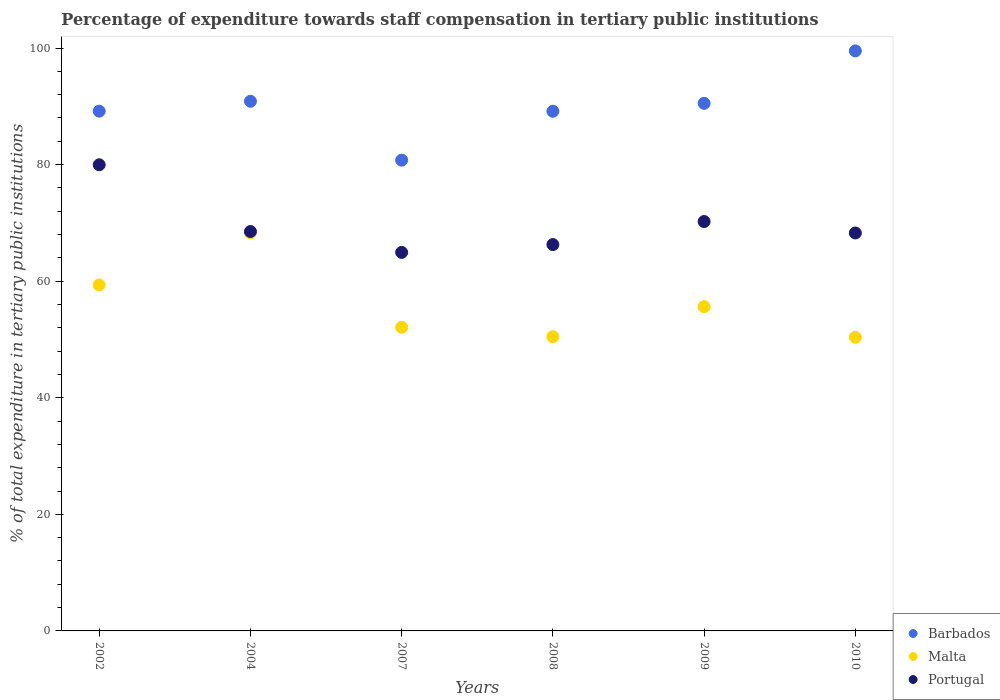How many different coloured dotlines are there?
Offer a terse response. 3. Is the number of dotlines equal to the number of legend labels?
Provide a succinct answer. Yes. What is the percentage of expenditure towards staff compensation in Malta in 2004?
Your response must be concise. 68.29. Across all years, what is the maximum percentage of expenditure towards staff compensation in Barbados?
Give a very brief answer. 99.51. Across all years, what is the minimum percentage of expenditure towards staff compensation in Barbados?
Provide a short and direct response. 80.77. In which year was the percentage of expenditure towards staff compensation in Barbados maximum?
Your response must be concise. 2010. In which year was the percentage of expenditure towards staff compensation in Barbados minimum?
Offer a terse response. 2007. What is the total percentage of expenditure towards staff compensation in Portugal in the graph?
Offer a very short reply. 418.22. What is the difference between the percentage of expenditure towards staff compensation in Portugal in 2004 and that in 2007?
Your answer should be compact. 3.59. What is the difference between the percentage of expenditure towards staff compensation in Portugal in 2002 and the percentage of expenditure towards staff compensation in Malta in 2010?
Provide a succinct answer. 29.59. What is the average percentage of expenditure towards staff compensation in Barbados per year?
Ensure brevity in your answer.  90. In the year 2004, what is the difference between the percentage of expenditure towards staff compensation in Barbados and percentage of expenditure towards staff compensation in Portugal?
Make the answer very short. 22.34. In how many years, is the percentage of expenditure towards staff compensation in Barbados greater than 24 %?
Offer a very short reply. 6. What is the ratio of the percentage of expenditure towards staff compensation in Barbados in 2004 to that in 2008?
Your answer should be very brief. 1.02. Is the percentage of expenditure towards staff compensation in Barbados in 2007 less than that in 2008?
Ensure brevity in your answer.  Yes. Is the difference between the percentage of expenditure towards staff compensation in Barbados in 2007 and 2009 greater than the difference between the percentage of expenditure towards staff compensation in Portugal in 2007 and 2009?
Offer a terse response. No. What is the difference between the highest and the second highest percentage of expenditure towards staff compensation in Portugal?
Your answer should be compact. 9.74. What is the difference between the highest and the lowest percentage of expenditure towards staff compensation in Barbados?
Offer a terse response. 18.74. In how many years, is the percentage of expenditure towards staff compensation in Barbados greater than the average percentage of expenditure towards staff compensation in Barbados taken over all years?
Ensure brevity in your answer.  3. Is it the case that in every year, the sum of the percentage of expenditure towards staff compensation in Barbados and percentage of expenditure towards staff compensation in Portugal  is greater than the percentage of expenditure towards staff compensation in Malta?
Offer a very short reply. Yes. Does the percentage of expenditure towards staff compensation in Portugal monotonically increase over the years?
Give a very brief answer. No. Is the percentage of expenditure towards staff compensation in Portugal strictly greater than the percentage of expenditure towards staff compensation in Barbados over the years?
Provide a succinct answer. No. How many years are there in the graph?
Keep it short and to the point. 6. Are the values on the major ticks of Y-axis written in scientific E-notation?
Provide a succinct answer. No. Where does the legend appear in the graph?
Provide a succinct answer. Bottom right. What is the title of the graph?
Your response must be concise. Percentage of expenditure towards staff compensation in tertiary public institutions. Does "Sudan" appear as one of the legend labels in the graph?
Provide a short and direct response. No. What is the label or title of the X-axis?
Make the answer very short. Years. What is the label or title of the Y-axis?
Provide a short and direct response. % of total expenditure in tertiary public institutions. What is the % of total expenditure in tertiary public institutions in Barbados in 2002?
Make the answer very short. 89.17. What is the % of total expenditure in tertiary public institutions in Malta in 2002?
Give a very brief answer. 59.36. What is the % of total expenditure in tertiary public institutions of Portugal in 2002?
Offer a terse response. 79.97. What is the % of total expenditure in tertiary public institutions in Barbados in 2004?
Keep it short and to the point. 90.87. What is the % of total expenditure in tertiary public institutions of Malta in 2004?
Your response must be concise. 68.29. What is the % of total expenditure in tertiary public institutions in Portugal in 2004?
Keep it short and to the point. 68.52. What is the % of total expenditure in tertiary public institutions of Barbados in 2007?
Ensure brevity in your answer.  80.77. What is the % of total expenditure in tertiary public institutions of Malta in 2007?
Give a very brief answer. 52.09. What is the % of total expenditure in tertiary public institutions of Portugal in 2007?
Provide a succinct answer. 64.94. What is the % of total expenditure in tertiary public institutions of Barbados in 2008?
Ensure brevity in your answer.  89.15. What is the % of total expenditure in tertiary public institutions of Malta in 2008?
Provide a short and direct response. 50.48. What is the % of total expenditure in tertiary public institutions of Portugal in 2008?
Your response must be concise. 66.28. What is the % of total expenditure in tertiary public institutions in Barbados in 2009?
Keep it short and to the point. 90.51. What is the % of total expenditure in tertiary public institutions of Malta in 2009?
Your answer should be compact. 55.62. What is the % of total expenditure in tertiary public institutions of Portugal in 2009?
Make the answer very short. 70.24. What is the % of total expenditure in tertiary public institutions of Barbados in 2010?
Your answer should be very brief. 99.51. What is the % of total expenditure in tertiary public institutions of Malta in 2010?
Your response must be concise. 50.38. What is the % of total expenditure in tertiary public institutions in Portugal in 2010?
Provide a succinct answer. 68.27. Across all years, what is the maximum % of total expenditure in tertiary public institutions of Barbados?
Provide a short and direct response. 99.51. Across all years, what is the maximum % of total expenditure in tertiary public institutions of Malta?
Your answer should be very brief. 68.29. Across all years, what is the maximum % of total expenditure in tertiary public institutions in Portugal?
Provide a short and direct response. 79.97. Across all years, what is the minimum % of total expenditure in tertiary public institutions in Barbados?
Provide a succinct answer. 80.77. Across all years, what is the minimum % of total expenditure in tertiary public institutions of Malta?
Your answer should be compact. 50.38. Across all years, what is the minimum % of total expenditure in tertiary public institutions in Portugal?
Give a very brief answer. 64.94. What is the total % of total expenditure in tertiary public institutions of Barbados in the graph?
Keep it short and to the point. 539.98. What is the total % of total expenditure in tertiary public institutions of Malta in the graph?
Offer a terse response. 336.22. What is the total % of total expenditure in tertiary public institutions of Portugal in the graph?
Ensure brevity in your answer.  418.22. What is the difference between the % of total expenditure in tertiary public institutions of Barbados in 2002 and that in 2004?
Ensure brevity in your answer.  -1.7. What is the difference between the % of total expenditure in tertiary public institutions of Malta in 2002 and that in 2004?
Offer a terse response. -8.93. What is the difference between the % of total expenditure in tertiary public institutions of Portugal in 2002 and that in 2004?
Keep it short and to the point. 11.45. What is the difference between the % of total expenditure in tertiary public institutions in Barbados in 2002 and that in 2007?
Offer a very short reply. 8.4. What is the difference between the % of total expenditure in tertiary public institutions in Malta in 2002 and that in 2007?
Your answer should be compact. 7.26. What is the difference between the % of total expenditure in tertiary public institutions in Portugal in 2002 and that in 2007?
Provide a short and direct response. 15.04. What is the difference between the % of total expenditure in tertiary public institutions in Barbados in 2002 and that in 2008?
Provide a short and direct response. 0.02. What is the difference between the % of total expenditure in tertiary public institutions in Malta in 2002 and that in 2008?
Give a very brief answer. 8.87. What is the difference between the % of total expenditure in tertiary public institutions of Portugal in 2002 and that in 2008?
Ensure brevity in your answer.  13.69. What is the difference between the % of total expenditure in tertiary public institutions of Barbados in 2002 and that in 2009?
Make the answer very short. -1.34. What is the difference between the % of total expenditure in tertiary public institutions in Malta in 2002 and that in 2009?
Provide a succinct answer. 3.73. What is the difference between the % of total expenditure in tertiary public institutions of Portugal in 2002 and that in 2009?
Your answer should be compact. 9.74. What is the difference between the % of total expenditure in tertiary public institutions in Barbados in 2002 and that in 2010?
Your answer should be compact. -10.34. What is the difference between the % of total expenditure in tertiary public institutions in Malta in 2002 and that in 2010?
Provide a short and direct response. 8.98. What is the difference between the % of total expenditure in tertiary public institutions of Portugal in 2002 and that in 2010?
Your answer should be compact. 11.7. What is the difference between the % of total expenditure in tertiary public institutions in Barbados in 2004 and that in 2007?
Provide a short and direct response. 10.1. What is the difference between the % of total expenditure in tertiary public institutions of Malta in 2004 and that in 2007?
Your answer should be compact. 16.2. What is the difference between the % of total expenditure in tertiary public institutions of Portugal in 2004 and that in 2007?
Keep it short and to the point. 3.59. What is the difference between the % of total expenditure in tertiary public institutions in Barbados in 2004 and that in 2008?
Make the answer very short. 1.72. What is the difference between the % of total expenditure in tertiary public institutions of Malta in 2004 and that in 2008?
Provide a short and direct response. 17.81. What is the difference between the % of total expenditure in tertiary public institutions of Portugal in 2004 and that in 2008?
Give a very brief answer. 2.24. What is the difference between the % of total expenditure in tertiary public institutions in Barbados in 2004 and that in 2009?
Provide a succinct answer. 0.36. What is the difference between the % of total expenditure in tertiary public institutions in Malta in 2004 and that in 2009?
Your response must be concise. 12.66. What is the difference between the % of total expenditure in tertiary public institutions of Portugal in 2004 and that in 2009?
Your answer should be very brief. -1.71. What is the difference between the % of total expenditure in tertiary public institutions in Barbados in 2004 and that in 2010?
Offer a terse response. -8.64. What is the difference between the % of total expenditure in tertiary public institutions in Malta in 2004 and that in 2010?
Ensure brevity in your answer.  17.91. What is the difference between the % of total expenditure in tertiary public institutions of Portugal in 2004 and that in 2010?
Keep it short and to the point. 0.25. What is the difference between the % of total expenditure in tertiary public institutions in Barbados in 2007 and that in 2008?
Offer a terse response. -8.38. What is the difference between the % of total expenditure in tertiary public institutions of Malta in 2007 and that in 2008?
Ensure brevity in your answer.  1.61. What is the difference between the % of total expenditure in tertiary public institutions in Portugal in 2007 and that in 2008?
Offer a very short reply. -1.35. What is the difference between the % of total expenditure in tertiary public institutions of Barbados in 2007 and that in 2009?
Provide a succinct answer. -9.74. What is the difference between the % of total expenditure in tertiary public institutions of Malta in 2007 and that in 2009?
Ensure brevity in your answer.  -3.53. What is the difference between the % of total expenditure in tertiary public institutions of Portugal in 2007 and that in 2009?
Your answer should be compact. -5.3. What is the difference between the % of total expenditure in tertiary public institutions of Barbados in 2007 and that in 2010?
Make the answer very short. -18.74. What is the difference between the % of total expenditure in tertiary public institutions in Malta in 2007 and that in 2010?
Provide a short and direct response. 1.72. What is the difference between the % of total expenditure in tertiary public institutions of Portugal in 2007 and that in 2010?
Your answer should be very brief. -3.33. What is the difference between the % of total expenditure in tertiary public institutions in Barbados in 2008 and that in 2009?
Your response must be concise. -1.36. What is the difference between the % of total expenditure in tertiary public institutions in Malta in 2008 and that in 2009?
Give a very brief answer. -5.14. What is the difference between the % of total expenditure in tertiary public institutions of Portugal in 2008 and that in 2009?
Make the answer very short. -3.95. What is the difference between the % of total expenditure in tertiary public institutions in Barbados in 2008 and that in 2010?
Your answer should be very brief. -10.36. What is the difference between the % of total expenditure in tertiary public institutions of Malta in 2008 and that in 2010?
Offer a very short reply. 0.11. What is the difference between the % of total expenditure in tertiary public institutions in Portugal in 2008 and that in 2010?
Your response must be concise. -1.99. What is the difference between the % of total expenditure in tertiary public institutions of Barbados in 2009 and that in 2010?
Provide a succinct answer. -9. What is the difference between the % of total expenditure in tertiary public institutions in Malta in 2009 and that in 2010?
Your answer should be very brief. 5.25. What is the difference between the % of total expenditure in tertiary public institutions of Portugal in 2009 and that in 2010?
Offer a very short reply. 1.96. What is the difference between the % of total expenditure in tertiary public institutions in Barbados in 2002 and the % of total expenditure in tertiary public institutions in Malta in 2004?
Keep it short and to the point. 20.88. What is the difference between the % of total expenditure in tertiary public institutions of Barbados in 2002 and the % of total expenditure in tertiary public institutions of Portugal in 2004?
Ensure brevity in your answer.  20.65. What is the difference between the % of total expenditure in tertiary public institutions of Malta in 2002 and the % of total expenditure in tertiary public institutions of Portugal in 2004?
Offer a very short reply. -9.17. What is the difference between the % of total expenditure in tertiary public institutions of Barbados in 2002 and the % of total expenditure in tertiary public institutions of Malta in 2007?
Your answer should be very brief. 37.08. What is the difference between the % of total expenditure in tertiary public institutions in Barbados in 2002 and the % of total expenditure in tertiary public institutions in Portugal in 2007?
Provide a short and direct response. 24.23. What is the difference between the % of total expenditure in tertiary public institutions of Malta in 2002 and the % of total expenditure in tertiary public institutions of Portugal in 2007?
Provide a succinct answer. -5.58. What is the difference between the % of total expenditure in tertiary public institutions in Barbados in 2002 and the % of total expenditure in tertiary public institutions in Malta in 2008?
Provide a succinct answer. 38.69. What is the difference between the % of total expenditure in tertiary public institutions of Barbados in 2002 and the % of total expenditure in tertiary public institutions of Portugal in 2008?
Make the answer very short. 22.89. What is the difference between the % of total expenditure in tertiary public institutions in Malta in 2002 and the % of total expenditure in tertiary public institutions in Portugal in 2008?
Keep it short and to the point. -6.93. What is the difference between the % of total expenditure in tertiary public institutions of Barbados in 2002 and the % of total expenditure in tertiary public institutions of Malta in 2009?
Ensure brevity in your answer.  33.54. What is the difference between the % of total expenditure in tertiary public institutions of Barbados in 2002 and the % of total expenditure in tertiary public institutions of Portugal in 2009?
Ensure brevity in your answer.  18.93. What is the difference between the % of total expenditure in tertiary public institutions of Malta in 2002 and the % of total expenditure in tertiary public institutions of Portugal in 2009?
Make the answer very short. -10.88. What is the difference between the % of total expenditure in tertiary public institutions in Barbados in 2002 and the % of total expenditure in tertiary public institutions in Malta in 2010?
Give a very brief answer. 38.79. What is the difference between the % of total expenditure in tertiary public institutions of Barbados in 2002 and the % of total expenditure in tertiary public institutions of Portugal in 2010?
Provide a succinct answer. 20.9. What is the difference between the % of total expenditure in tertiary public institutions of Malta in 2002 and the % of total expenditure in tertiary public institutions of Portugal in 2010?
Your response must be concise. -8.92. What is the difference between the % of total expenditure in tertiary public institutions of Barbados in 2004 and the % of total expenditure in tertiary public institutions of Malta in 2007?
Your answer should be very brief. 38.77. What is the difference between the % of total expenditure in tertiary public institutions of Barbados in 2004 and the % of total expenditure in tertiary public institutions of Portugal in 2007?
Provide a succinct answer. 25.93. What is the difference between the % of total expenditure in tertiary public institutions of Malta in 2004 and the % of total expenditure in tertiary public institutions of Portugal in 2007?
Your response must be concise. 3.35. What is the difference between the % of total expenditure in tertiary public institutions of Barbados in 2004 and the % of total expenditure in tertiary public institutions of Malta in 2008?
Your answer should be compact. 40.38. What is the difference between the % of total expenditure in tertiary public institutions of Barbados in 2004 and the % of total expenditure in tertiary public institutions of Portugal in 2008?
Your answer should be very brief. 24.58. What is the difference between the % of total expenditure in tertiary public institutions in Malta in 2004 and the % of total expenditure in tertiary public institutions in Portugal in 2008?
Your answer should be very brief. 2.01. What is the difference between the % of total expenditure in tertiary public institutions of Barbados in 2004 and the % of total expenditure in tertiary public institutions of Malta in 2009?
Offer a very short reply. 35.24. What is the difference between the % of total expenditure in tertiary public institutions in Barbados in 2004 and the % of total expenditure in tertiary public institutions in Portugal in 2009?
Keep it short and to the point. 20.63. What is the difference between the % of total expenditure in tertiary public institutions in Malta in 2004 and the % of total expenditure in tertiary public institutions in Portugal in 2009?
Your answer should be very brief. -1.95. What is the difference between the % of total expenditure in tertiary public institutions in Barbados in 2004 and the % of total expenditure in tertiary public institutions in Malta in 2010?
Make the answer very short. 40.49. What is the difference between the % of total expenditure in tertiary public institutions in Barbados in 2004 and the % of total expenditure in tertiary public institutions in Portugal in 2010?
Provide a succinct answer. 22.59. What is the difference between the % of total expenditure in tertiary public institutions of Malta in 2004 and the % of total expenditure in tertiary public institutions of Portugal in 2010?
Offer a very short reply. 0.02. What is the difference between the % of total expenditure in tertiary public institutions in Barbados in 2007 and the % of total expenditure in tertiary public institutions in Malta in 2008?
Make the answer very short. 30.28. What is the difference between the % of total expenditure in tertiary public institutions of Barbados in 2007 and the % of total expenditure in tertiary public institutions of Portugal in 2008?
Offer a terse response. 14.48. What is the difference between the % of total expenditure in tertiary public institutions of Malta in 2007 and the % of total expenditure in tertiary public institutions of Portugal in 2008?
Make the answer very short. -14.19. What is the difference between the % of total expenditure in tertiary public institutions of Barbados in 2007 and the % of total expenditure in tertiary public institutions of Malta in 2009?
Your response must be concise. 25.14. What is the difference between the % of total expenditure in tertiary public institutions in Barbados in 2007 and the % of total expenditure in tertiary public institutions in Portugal in 2009?
Make the answer very short. 10.53. What is the difference between the % of total expenditure in tertiary public institutions in Malta in 2007 and the % of total expenditure in tertiary public institutions in Portugal in 2009?
Keep it short and to the point. -18.14. What is the difference between the % of total expenditure in tertiary public institutions in Barbados in 2007 and the % of total expenditure in tertiary public institutions in Malta in 2010?
Make the answer very short. 30.39. What is the difference between the % of total expenditure in tertiary public institutions of Barbados in 2007 and the % of total expenditure in tertiary public institutions of Portugal in 2010?
Offer a terse response. 12.5. What is the difference between the % of total expenditure in tertiary public institutions in Malta in 2007 and the % of total expenditure in tertiary public institutions in Portugal in 2010?
Your answer should be very brief. -16.18. What is the difference between the % of total expenditure in tertiary public institutions in Barbados in 2008 and the % of total expenditure in tertiary public institutions in Malta in 2009?
Your answer should be very brief. 33.53. What is the difference between the % of total expenditure in tertiary public institutions in Barbados in 2008 and the % of total expenditure in tertiary public institutions in Portugal in 2009?
Provide a succinct answer. 18.92. What is the difference between the % of total expenditure in tertiary public institutions of Malta in 2008 and the % of total expenditure in tertiary public institutions of Portugal in 2009?
Offer a very short reply. -19.75. What is the difference between the % of total expenditure in tertiary public institutions in Barbados in 2008 and the % of total expenditure in tertiary public institutions in Malta in 2010?
Your answer should be compact. 38.77. What is the difference between the % of total expenditure in tertiary public institutions in Barbados in 2008 and the % of total expenditure in tertiary public institutions in Portugal in 2010?
Provide a succinct answer. 20.88. What is the difference between the % of total expenditure in tertiary public institutions in Malta in 2008 and the % of total expenditure in tertiary public institutions in Portugal in 2010?
Make the answer very short. -17.79. What is the difference between the % of total expenditure in tertiary public institutions of Barbados in 2009 and the % of total expenditure in tertiary public institutions of Malta in 2010?
Your response must be concise. 40.13. What is the difference between the % of total expenditure in tertiary public institutions in Barbados in 2009 and the % of total expenditure in tertiary public institutions in Portugal in 2010?
Your answer should be very brief. 22.24. What is the difference between the % of total expenditure in tertiary public institutions of Malta in 2009 and the % of total expenditure in tertiary public institutions of Portugal in 2010?
Your response must be concise. -12.65. What is the average % of total expenditure in tertiary public institutions of Barbados per year?
Your response must be concise. 90. What is the average % of total expenditure in tertiary public institutions in Malta per year?
Provide a succinct answer. 56.04. What is the average % of total expenditure in tertiary public institutions in Portugal per year?
Keep it short and to the point. 69.7. In the year 2002, what is the difference between the % of total expenditure in tertiary public institutions of Barbados and % of total expenditure in tertiary public institutions of Malta?
Offer a terse response. 29.81. In the year 2002, what is the difference between the % of total expenditure in tertiary public institutions in Barbados and % of total expenditure in tertiary public institutions in Portugal?
Offer a very short reply. 9.2. In the year 2002, what is the difference between the % of total expenditure in tertiary public institutions of Malta and % of total expenditure in tertiary public institutions of Portugal?
Keep it short and to the point. -20.62. In the year 2004, what is the difference between the % of total expenditure in tertiary public institutions in Barbados and % of total expenditure in tertiary public institutions in Malta?
Your response must be concise. 22.58. In the year 2004, what is the difference between the % of total expenditure in tertiary public institutions in Barbados and % of total expenditure in tertiary public institutions in Portugal?
Make the answer very short. 22.34. In the year 2004, what is the difference between the % of total expenditure in tertiary public institutions of Malta and % of total expenditure in tertiary public institutions of Portugal?
Your answer should be very brief. -0.23. In the year 2007, what is the difference between the % of total expenditure in tertiary public institutions of Barbados and % of total expenditure in tertiary public institutions of Malta?
Make the answer very short. 28.68. In the year 2007, what is the difference between the % of total expenditure in tertiary public institutions of Barbados and % of total expenditure in tertiary public institutions of Portugal?
Your answer should be compact. 15.83. In the year 2007, what is the difference between the % of total expenditure in tertiary public institutions of Malta and % of total expenditure in tertiary public institutions of Portugal?
Make the answer very short. -12.84. In the year 2008, what is the difference between the % of total expenditure in tertiary public institutions of Barbados and % of total expenditure in tertiary public institutions of Malta?
Make the answer very short. 38.67. In the year 2008, what is the difference between the % of total expenditure in tertiary public institutions of Barbados and % of total expenditure in tertiary public institutions of Portugal?
Your response must be concise. 22.87. In the year 2008, what is the difference between the % of total expenditure in tertiary public institutions of Malta and % of total expenditure in tertiary public institutions of Portugal?
Keep it short and to the point. -15.8. In the year 2009, what is the difference between the % of total expenditure in tertiary public institutions in Barbados and % of total expenditure in tertiary public institutions in Malta?
Make the answer very short. 34.89. In the year 2009, what is the difference between the % of total expenditure in tertiary public institutions of Barbados and % of total expenditure in tertiary public institutions of Portugal?
Provide a short and direct response. 20.27. In the year 2009, what is the difference between the % of total expenditure in tertiary public institutions in Malta and % of total expenditure in tertiary public institutions in Portugal?
Provide a succinct answer. -14.61. In the year 2010, what is the difference between the % of total expenditure in tertiary public institutions in Barbados and % of total expenditure in tertiary public institutions in Malta?
Keep it short and to the point. 49.13. In the year 2010, what is the difference between the % of total expenditure in tertiary public institutions in Barbados and % of total expenditure in tertiary public institutions in Portugal?
Keep it short and to the point. 31.24. In the year 2010, what is the difference between the % of total expenditure in tertiary public institutions of Malta and % of total expenditure in tertiary public institutions of Portugal?
Make the answer very short. -17.89. What is the ratio of the % of total expenditure in tertiary public institutions of Barbados in 2002 to that in 2004?
Offer a terse response. 0.98. What is the ratio of the % of total expenditure in tertiary public institutions of Malta in 2002 to that in 2004?
Your response must be concise. 0.87. What is the ratio of the % of total expenditure in tertiary public institutions of Portugal in 2002 to that in 2004?
Your answer should be compact. 1.17. What is the ratio of the % of total expenditure in tertiary public institutions of Barbados in 2002 to that in 2007?
Provide a short and direct response. 1.1. What is the ratio of the % of total expenditure in tertiary public institutions of Malta in 2002 to that in 2007?
Keep it short and to the point. 1.14. What is the ratio of the % of total expenditure in tertiary public institutions of Portugal in 2002 to that in 2007?
Ensure brevity in your answer.  1.23. What is the ratio of the % of total expenditure in tertiary public institutions in Barbados in 2002 to that in 2008?
Ensure brevity in your answer.  1. What is the ratio of the % of total expenditure in tertiary public institutions in Malta in 2002 to that in 2008?
Your answer should be compact. 1.18. What is the ratio of the % of total expenditure in tertiary public institutions of Portugal in 2002 to that in 2008?
Your answer should be compact. 1.21. What is the ratio of the % of total expenditure in tertiary public institutions of Barbados in 2002 to that in 2009?
Offer a very short reply. 0.99. What is the ratio of the % of total expenditure in tertiary public institutions in Malta in 2002 to that in 2009?
Offer a very short reply. 1.07. What is the ratio of the % of total expenditure in tertiary public institutions of Portugal in 2002 to that in 2009?
Offer a very short reply. 1.14. What is the ratio of the % of total expenditure in tertiary public institutions in Barbados in 2002 to that in 2010?
Offer a very short reply. 0.9. What is the ratio of the % of total expenditure in tertiary public institutions in Malta in 2002 to that in 2010?
Offer a terse response. 1.18. What is the ratio of the % of total expenditure in tertiary public institutions of Portugal in 2002 to that in 2010?
Provide a succinct answer. 1.17. What is the ratio of the % of total expenditure in tertiary public institutions in Malta in 2004 to that in 2007?
Provide a succinct answer. 1.31. What is the ratio of the % of total expenditure in tertiary public institutions of Portugal in 2004 to that in 2007?
Ensure brevity in your answer.  1.06. What is the ratio of the % of total expenditure in tertiary public institutions of Barbados in 2004 to that in 2008?
Keep it short and to the point. 1.02. What is the ratio of the % of total expenditure in tertiary public institutions of Malta in 2004 to that in 2008?
Give a very brief answer. 1.35. What is the ratio of the % of total expenditure in tertiary public institutions in Portugal in 2004 to that in 2008?
Make the answer very short. 1.03. What is the ratio of the % of total expenditure in tertiary public institutions of Barbados in 2004 to that in 2009?
Provide a short and direct response. 1. What is the ratio of the % of total expenditure in tertiary public institutions of Malta in 2004 to that in 2009?
Provide a succinct answer. 1.23. What is the ratio of the % of total expenditure in tertiary public institutions in Portugal in 2004 to that in 2009?
Your answer should be very brief. 0.98. What is the ratio of the % of total expenditure in tertiary public institutions of Barbados in 2004 to that in 2010?
Ensure brevity in your answer.  0.91. What is the ratio of the % of total expenditure in tertiary public institutions in Malta in 2004 to that in 2010?
Offer a terse response. 1.36. What is the ratio of the % of total expenditure in tertiary public institutions in Barbados in 2007 to that in 2008?
Provide a succinct answer. 0.91. What is the ratio of the % of total expenditure in tertiary public institutions in Malta in 2007 to that in 2008?
Offer a terse response. 1.03. What is the ratio of the % of total expenditure in tertiary public institutions in Portugal in 2007 to that in 2008?
Your answer should be very brief. 0.98. What is the ratio of the % of total expenditure in tertiary public institutions in Barbados in 2007 to that in 2009?
Ensure brevity in your answer.  0.89. What is the ratio of the % of total expenditure in tertiary public institutions in Malta in 2007 to that in 2009?
Make the answer very short. 0.94. What is the ratio of the % of total expenditure in tertiary public institutions of Portugal in 2007 to that in 2009?
Your response must be concise. 0.92. What is the ratio of the % of total expenditure in tertiary public institutions in Barbados in 2007 to that in 2010?
Your response must be concise. 0.81. What is the ratio of the % of total expenditure in tertiary public institutions of Malta in 2007 to that in 2010?
Provide a succinct answer. 1.03. What is the ratio of the % of total expenditure in tertiary public institutions of Portugal in 2007 to that in 2010?
Give a very brief answer. 0.95. What is the ratio of the % of total expenditure in tertiary public institutions in Barbados in 2008 to that in 2009?
Provide a succinct answer. 0.98. What is the ratio of the % of total expenditure in tertiary public institutions in Malta in 2008 to that in 2009?
Make the answer very short. 0.91. What is the ratio of the % of total expenditure in tertiary public institutions of Portugal in 2008 to that in 2009?
Offer a terse response. 0.94. What is the ratio of the % of total expenditure in tertiary public institutions in Barbados in 2008 to that in 2010?
Provide a succinct answer. 0.9. What is the ratio of the % of total expenditure in tertiary public institutions in Malta in 2008 to that in 2010?
Ensure brevity in your answer.  1. What is the ratio of the % of total expenditure in tertiary public institutions of Portugal in 2008 to that in 2010?
Your response must be concise. 0.97. What is the ratio of the % of total expenditure in tertiary public institutions of Barbados in 2009 to that in 2010?
Your answer should be compact. 0.91. What is the ratio of the % of total expenditure in tertiary public institutions of Malta in 2009 to that in 2010?
Your answer should be compact. 1.1. What is the ratio of the % of total expenditure in tertiary public institutions of Portugal in 2009 to that in 2010?
Make the answer very short. 1.03. What is the difference between the highest and the second highest % of total expenditure in tertiary public institutions in Barbados?
Your answer should be compact. 8.64. What is the difference between the highest and the second highest % of total expenditure in tertiary public institutions of Malta?
Your response must be concise. 8.93. What is the difference between the highest and the second highest % of total expenditure in tertiary public institutions in Portugal?
Your answer should be compact. 9.74. What is the difference between the highest and the lowest % of total expenditure in tertiary public institutions in Barbados?
Provide a succinct answer. 18.74. What is the difference between the highest and the lowest % of total expenditure in tertiary public institutions in Malta?
Provide a succinct answer. 17.91. What is the difference between the highest and the lowest % of total expenditure in tertiary public institutions of Portugal?
Your answer should be compact. 15.04. 